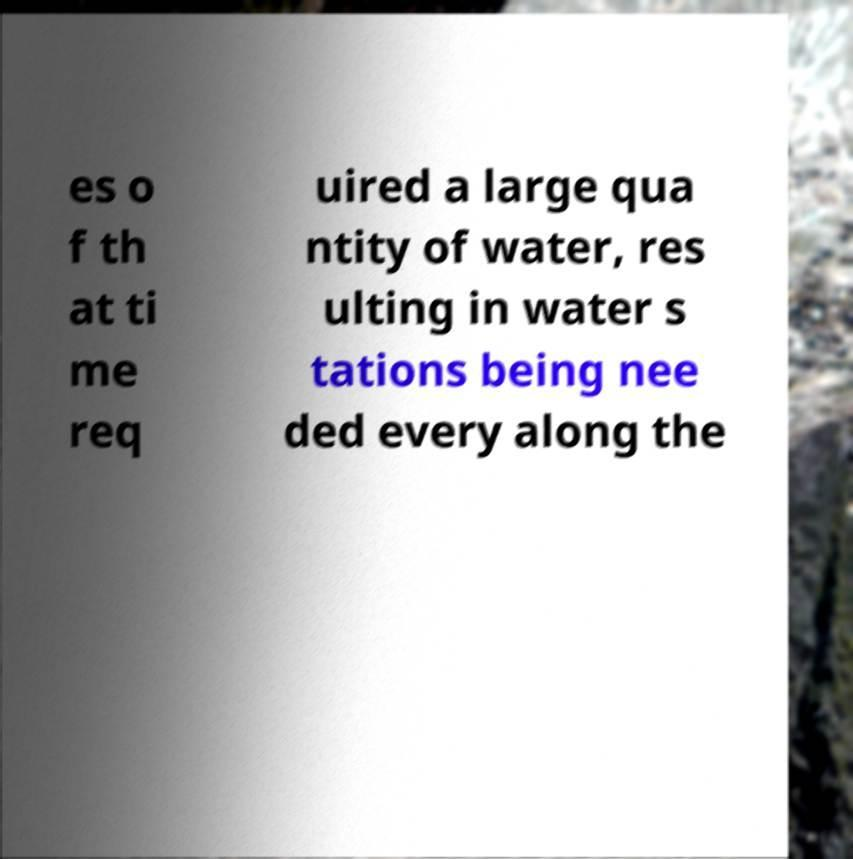Please read and relay the text visible in this image. What does it say? es o f th at ti me req uired a large qua ntity of water, res ulting in water s tations being nee ded every along the 